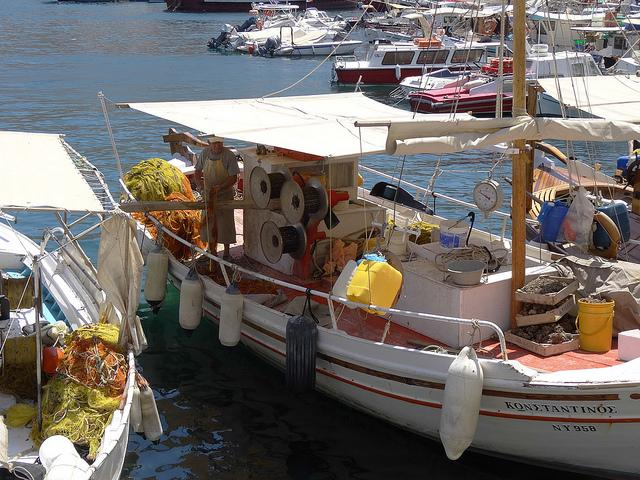What sort of method is used to secure these vessels to the shore?

Choices:
A) knots
B) oars
C) motors
D) dolphins knots 